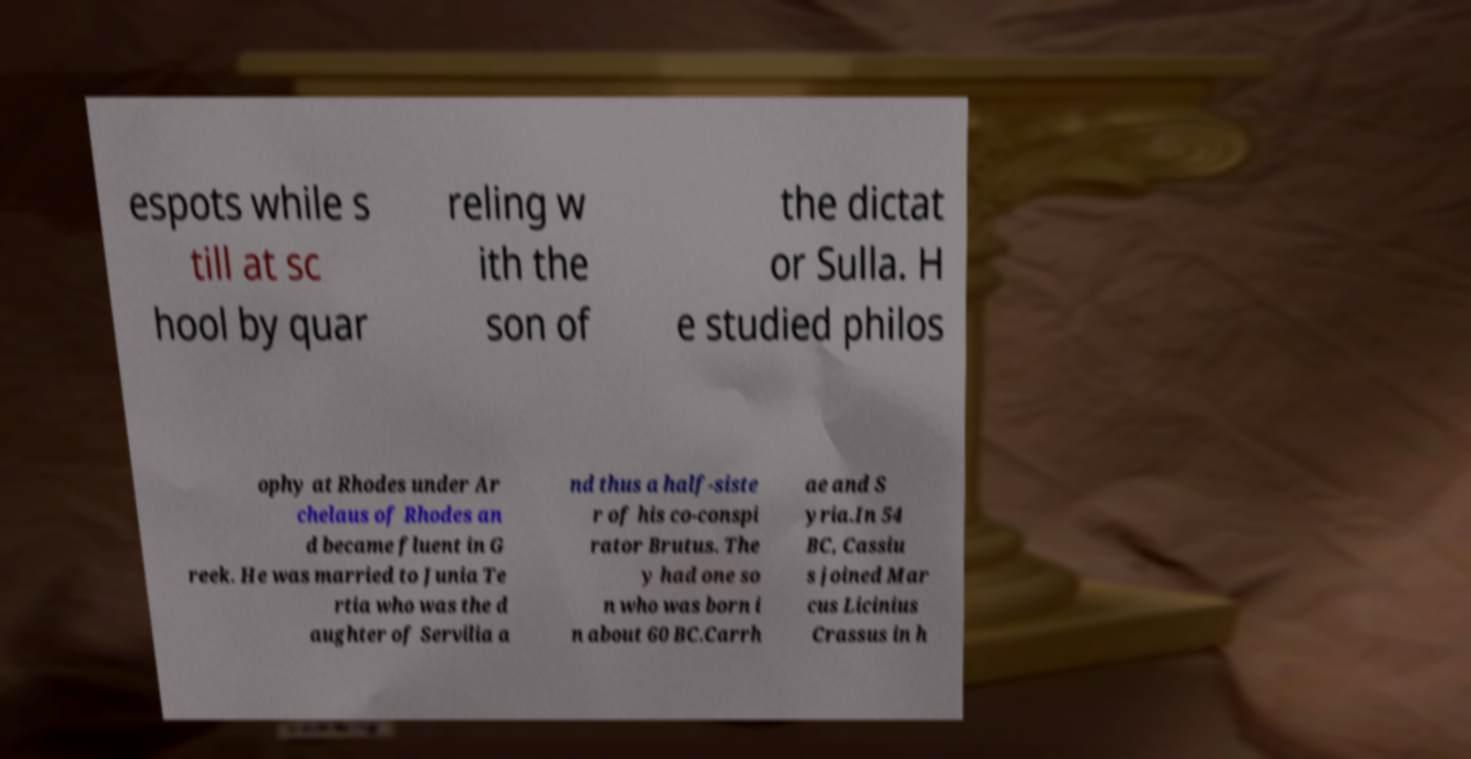Can you accurately transcribe the text from the provided image for me? espots while s till at sc hool by quar reling w ith the son of the dictat or Sulla. H e studied philos ophy at Rhodes under Ar chelaus of Rhodes an d became fluent in G reek. He was married to Junia Te rtia who was the d aughter of Servilia a nd thus a half-siste r of his co-conspi rator Brutus. The y had one so n who was born i n about 60 BC.Carrh ae and S yria.In 54 BC, Cassiu s joined Mar cus Licinius Crassus in h 